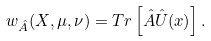Convert formula to latex. <formula><loc_0><loc_0><loc_500><loc_500>w _ { \hat { A } } ( X , \mu , \nu ) = T r \left [ \hat { A } \hat { U } ( { x } ) \right ] .</formula> 